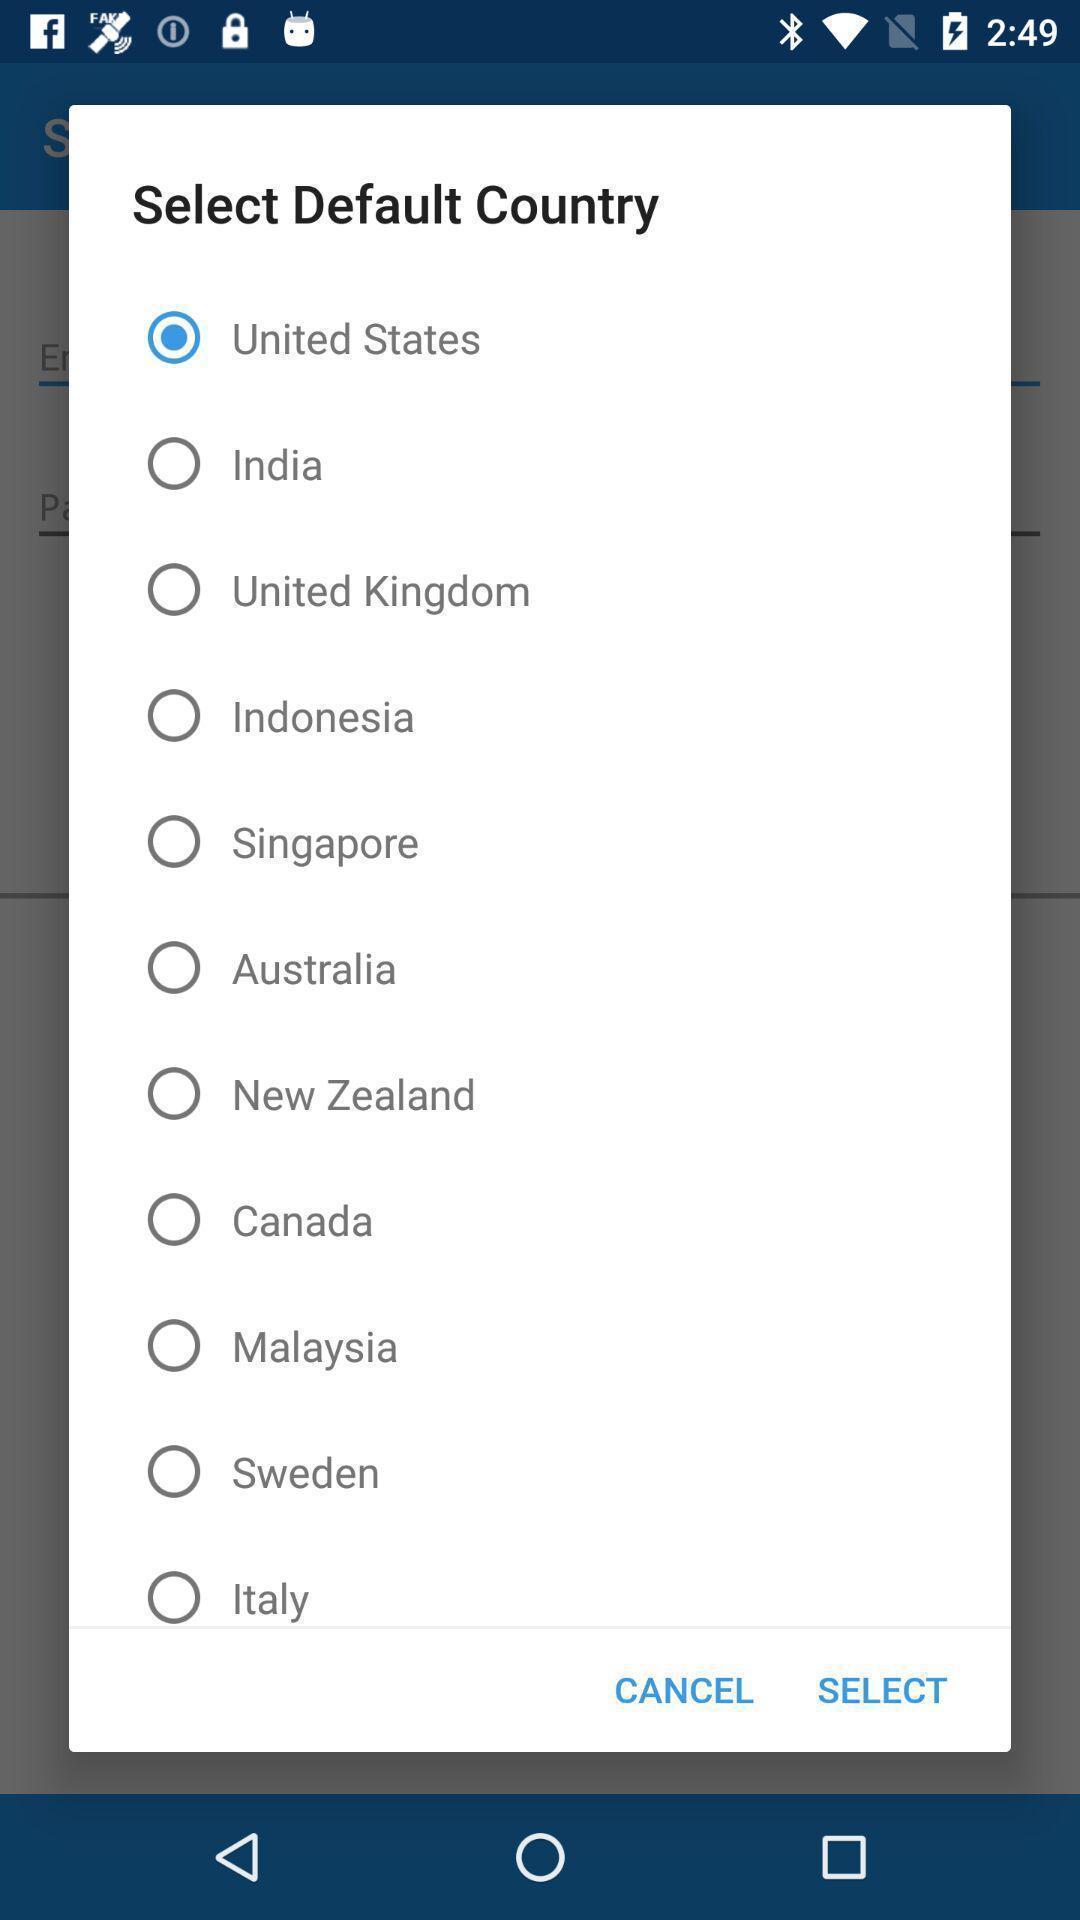Please provide a description for this image. Popup to select the country in the application. 